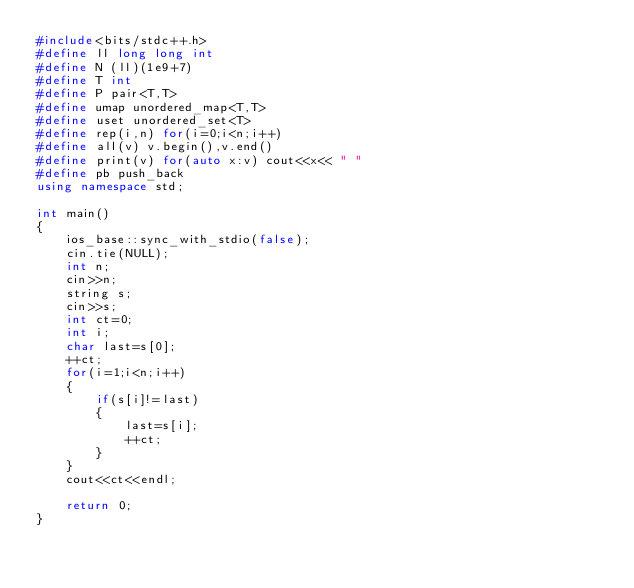Convert code to text. <code><loc_0><loc_0><loc_500><loc_500><_C++_>#include<bits/stdc++.h>
#define ll long long int
#define N (ll)(1e9+7)
#define T int
#define P pair<T,T>
#define umap unordered_map<T,T>
#define uset unordered_set<T>
#define rep(i,n) for(i=0;i<n;i++)
#define all(v) v.begin(),v.end()
#define print(v) for(auto x:v) cout<<x<< " "
#define pb push_back
using namespace std;

int main()
{
    ios_base::sync_with_stdio(false);
    cin.tie(NULL);
    int n;
    cin>>n;
    string s;
    cin>>s;
    int ct=0;
    int i;
    char last=s[0];
    ++ct;
    for(i=1;i<n;i++)
    {
        if(s[i]!=last)
        {
            last=s[i];
            ++ct;
        }
    }
    cout<<ct<<endl;

    return 0;
}
</code> 